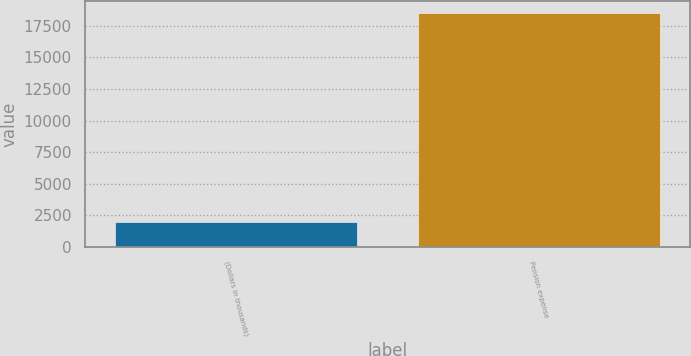Convert chart to OTSL. <chart><loc_0><loc_0><loc_500><loc_500><bar_chart><fcel>(Dollars in thousands)<fcel>Pension expense<nl><fcel>2014<fcel>18543<nl></chart> 